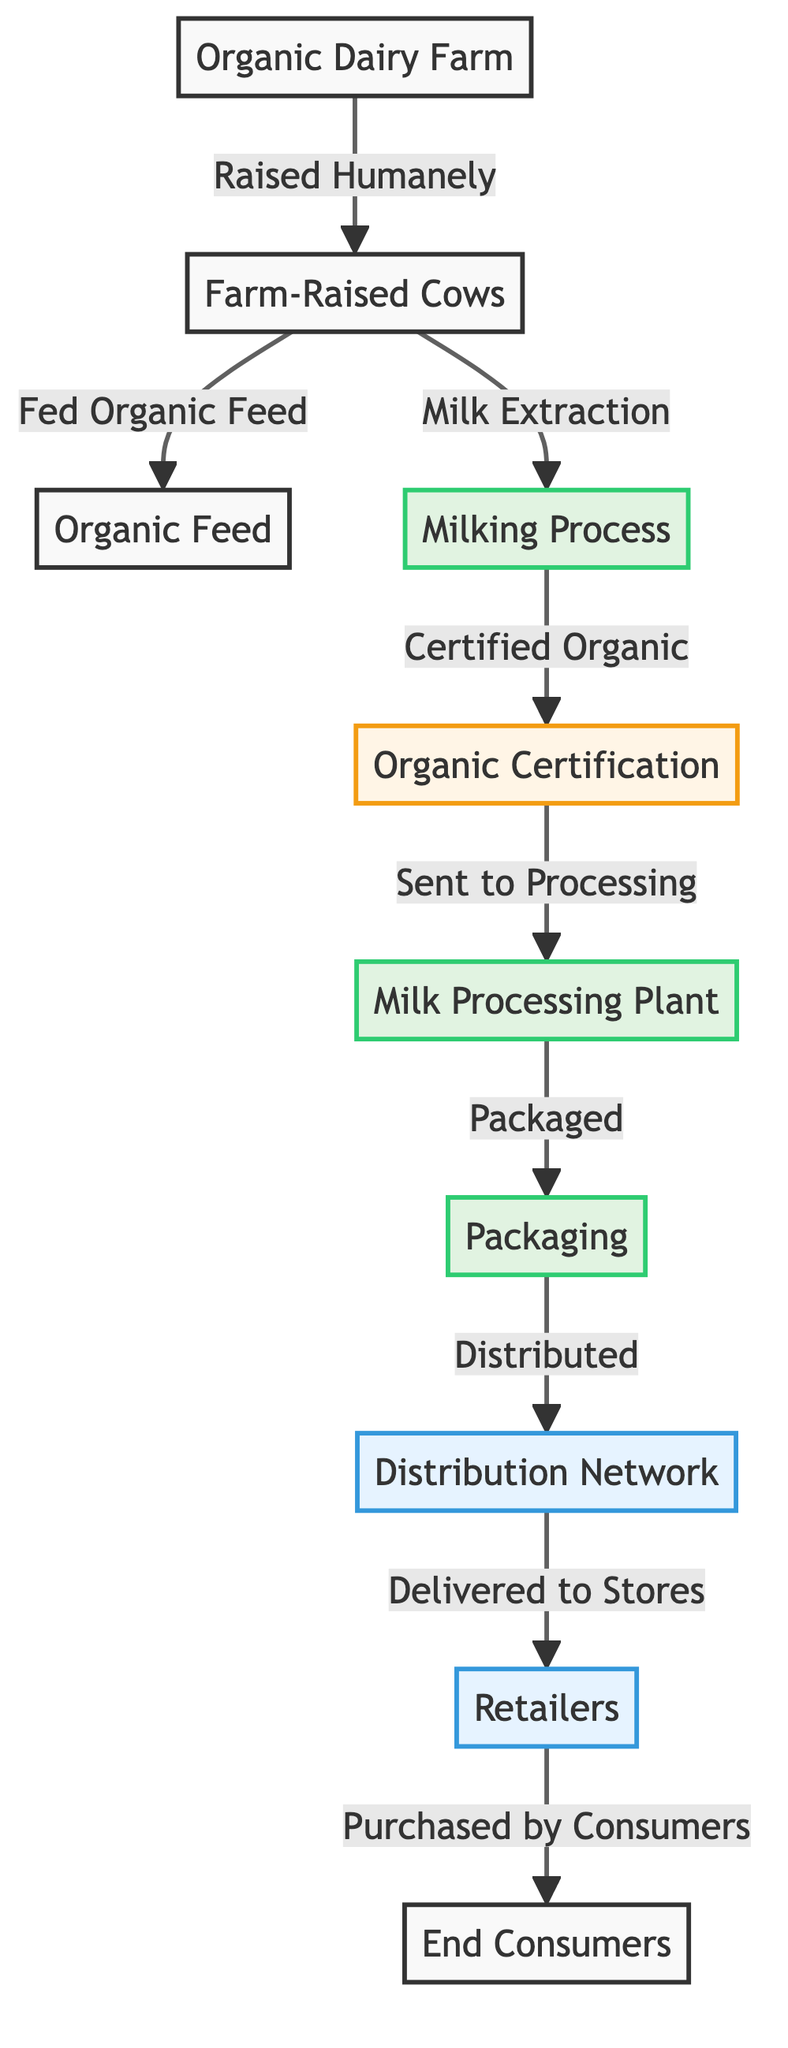What is the starting point of the organic dairy supply chain? The starting point is the "Organic Dairy Farm," which serves as the initial node in the diagram, representing where organic dairy products begin their journey.
Answer: Organic Dairy Farm How many main processes are involved in the production of organic dairy products? Counting from the diagram, there are three main processes identified: "Milking Process," "Milk Processing Plant," and "Packaging."
Answer: Three What step follows after the "Milking Process"? After the "Milking Process," the next step is "Organic Certification," which indicates the need for certification before moving to processing stages.
Answer: Organic Certification What do cows in the organic dairy farm consume? The cows are described in the diagram as being "Fed Organic Feed," which specifies the type of feed provided to ensure organic standards are met.
Answer: Organic Feed Which step involves direct interaction with consumers? The interaction with consumers occurs at the "Retailers" stage, where the packaged products are made available for purchase by the end consumers.
Answer: Retailers What certification is required after milking dairy cows? The necessary certification that must be obtained after the milking process is "Organic Certification," highlighting the quality and standards required for organic products.
Answer: Organic Certification How is the milk delivered to the end consumers? The delivery to consumers occurs through a series of stages starting from "Distribution Network," leading to "Retailers," and finally to "End Consumers." This illustrates the flow from production to purchase.
Answer: Distribution Network What ethical farming practice is highlighted in the supply chain? The diagram underscores that the cows are "Raised Humanely," an ethical farming practice that focuses on animal welfare throughout the supply chain.
Answer: Raised Humanely What happens to the milk after it is certified organic? Once the milk is certified organic, it is then sent to the "Processing" stage, where it undergoes further treatment before packaging.
Answer: Processing 